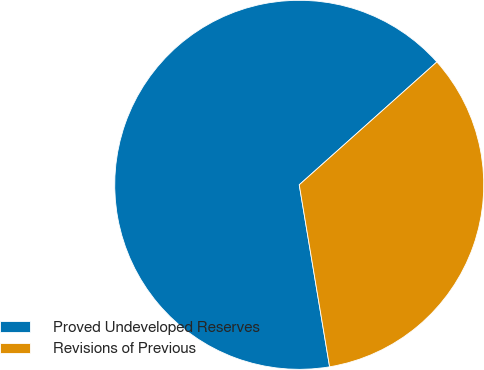Convert chart to OTSL. <chart><loc_0><loc_0><loc_500><loc_500><pie_chart><fcel>Proved Undeveloped Reserves<fcel>Revisions of Previous<nl><fcel>66.03%<fcel>33.97%<nl></chart> 